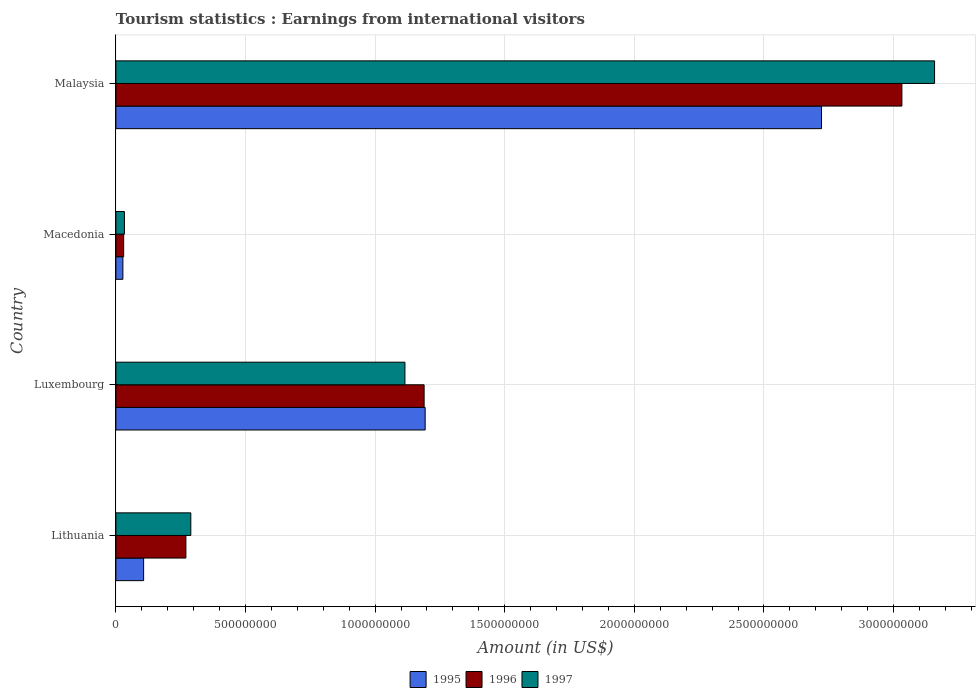Are the number of bars per tick equal to the number of legend labels?
Offer a very short reply. Yes. How many bars are there on the 1st tick from the top?
Provide a succinct answer. 3. How many bars are there on the 2nd tick from the bottom?
Offer a terse response. 3. What is the label of the 4th group of bars from the top?
Provide a succinct answer. Lithuania. In how many cases, is the number of bars for a given country not equal to the number of legend labels?
Provide a short and direct response. 0. What is the earnings from international visitors in 1996 in Lithuania?
Your response must be concise. 2.70e+08. Across all countries, what is the maximum earnings from international visitors in 1997?
Provide a succinct answer. 3.16e+09. Across all countries, what is the minimum earnings from international visitors in 1995?
Make the answer very short. 2.70e+07. In which country was the earnings from international visitors in 1995 maximum?
Make the answer very short. Malaysia. In which country was the earnings from international visitors in 1996 minimum?
Your response must be concise. Macedonia. What is the total earnings from international visitors in 1997 in the graph?
Keep it short and to the point. 4.60e+09. What is the difference between the earnings from international visitors in 1997 in Luxembourg and that in Malaysia?
Keep it short and to the point. -2.04e+09. What is the difference between the earnings from international visitors in 1996 in Luxembourg and the earnings from international visitors in 1997 in Macedonia?
Your answer should be compact. 1.16e+09. What is the average earnings from international visitors in 1995 per country?
Your response must be concise. 1.01e+09. What is the difference between the earnings from international visitors in 1996 and earnings from international visitors in 1995 in Malaysia?
Provide a succinct answer. 3.10e+08. In how many countries, is the earnings from international visitors in 1996 greater than 1900000000 US$?
Your response must be concise. 1. What is the ratio of the earnings from international visitors in 1995 in Lithuania to that in Macedonia?
Make the answer very short. 3.96. Is the earnings from international visitors in 1997 in Lithuania less than that in Macedonia?
Your answer should be compact. No. What is the difference between the highest and the second highest earnings from international visitors in 1997?
Offer a very short reply. 2.04e+09. What is the difference between the highest and the lowest earnings from international visitors in 1995?
Your answer should be very brief. 2.70e+09. Is the sum of the earnings from international visitors in 1995 in Lithuania and Macedonia greater than the maximum earnings from international visitors in 1996 across all countries?
Provide a short and direct response. No. What does the 3rd bar from the bottom in Luxembourg represents?
Offer a very short reply. 1997. Is it the case that in every country, the sum of the earnings from international visitors in 1997 and earnings from international visitors in 1995 is greater than the earnings from international visitors in 1996?
Provide a short and direct response. Yes. How many bars are there?
Offer a very short reply. 12. Are all the bars in the graph horizontal?
Give a very brief answer. Yes. Are the values on the major ticks of X-axis written in scientific E-notation?
Give a very brief answer. No. Does the graph contain grids?
Give a very brief answer. Yes. How are the legend labels stacked?
Give a very brief answer. Horizontal. What is the title of the graph?
Ensure brevity in your answer.  Tourism statistics : Earnings from international visitors. What is the label or title of the X-axis?
Give a very brief answer. Amount (in US$). What is the label or title of the Y-axis?
Provide a succinct answer. Country. What is the Amount (in US$) of 1995 in Lithuania?
Make the answer very short. 1.07e+08. What is the Amount (in US$) in 1996 in Lithuania?
Your response must be concise. 2.70e+08. What is the Amount (in US$) in 1997 in Lithuania?
Offer a very short reply. 2.89e+08. What is the Amount (in US$) in 1995 in Luxembourg?
Your response must be concise. 1.19e+09. What is the Amount (in US$) of 1996 in Luxembourg?
Provide a succinct answer. 1.19e+09. What is the Amount (in US$) of 1997 in Luxembourg?
Keep it short and to the point. 1.12e+09. What is the Amount (in US$) of 1995 in Macedonia?
Keep it short and to the point. 2.70e+07. What is the Amount (in US$) in 1996 in Macedonia?
Provide a succinct answer. 3.00e+07. What is the Amount (in US$) of 1997 in Macedonia?
Your answer should be very brief. 3.30e+07. What is the Amount (in US$) of 1995 in Malaysia?
Keep it short and to the point. 2.72e+09. What is the Amount (in US$) in 1996 in Malaysia?
Your answer should be compact. 3.03e+09. What is the Amount (in US$) in 1997 in Malaysia?
Your answer should be compact. 3.16e+09. Across all countries, what is the maximum Amount (in US$) in 1995?
Provide a succinct answer. 2.72e+09. Across all countries, what is the maximum Amount (in US$) in 1996?
Keep it short and to the point. 3.03e+09. Across all countries, what is the maximum Amount (in US$) of 1997?
Provide a short and direct response. 3.16e+09. Across all countries, what is the minimum Amount (in US$) in 1995?
Give a very brief answer. 2.70e+07. Across all countries, what is the minimum Amount (in US$) of 1996?
Your response must be concise. 3.00e+07. Across all countries, what is the minimum Amount (in US$) of 1997?
Your response must be concise. 3.30e+07. What is the total Amount (in US$) in 1995 in the graph?
Offer a very short reply. 4.05e+09. What is the total Amount (in US$) in 1996 in the graph?
Your answer should be very brief. 4.52e+09. What is the total Amount (in US$) in 1997 in the graph?
Give a very brief answer. 4.60e+09. What is the difference between the Amount (in US$) of 1995 in Lithuania and that in Luxembourg?
Your response must be concise. -1.09e+09. What is the difference between the Amount (in US$) in 1996 in Lithuania and that in Luxembourg?
Your answer should be very brief. -9.19e+08. What is the difference between the Amount (in US$) of 1997 in Lithuania and that in Luxembourg?
Ensure brevity in your answer.  -8.26e+08. What is the difference between the Amount (in US$) of 1995 in Lithuania and that in Macedonia?
Make the answer very short. 8.00e+07. What is the difference between the Amount (in US$) of 1996 in Lithuania and that in Macedonia?
Provide a succinct answer. 2.40e+08. What is the difference between the Amount (in US$) in 1997 in Lithuania and that in Macedonia?
Offer a very short reply. 2.56e+08. What is the difference between the Amount (in US$) of 1995 in Lithuania and that in Malaysia?
Your answer should be compact. -2.62e+09. What is the difference between the Amount (in US$) in 1996 in Lithuania and that in Malaysia?
Ensure brevity in your answer.  -2.76e+09. What is the difference between the Amount (in US$) of 1997 in Lithuania and that in Malaysia?
Keep it short and to the point. -2.87e+09. What is the difference between the Amount (in US$) of 1995 in Luxembourg and that in Macedonia?
Provide a short and direct response. 1.17e+09. What is the difference between the Amount (in US$) in 1996 in Luxembourg and that in Macedonia?
Offer a terse response. 1.16e+09. What is the difference between the Amount (in US$) in 1997 in Luxembourg and that in Macedonia?
Your answer should be very brief. 1.08e+09. What is the difference between the Amount (in US$) of 1995 in Luxembourg and that in Malaysia?
Keep it short and to the point. -1.53e+09. What is the difference between the Amount (in US$) of 1996 in Luxembourg and that in Malaysia?
Your answer should be compact. -1.84e+09. What is the difference between the Amount (in US$) in 1997 in Luxembourg and that in Malaysia?
Provide a succinct answer. -2.04e+09. What is the difference between the Amount (in US$) of 1995 in Macedonia and that in Malaysia?
Your response must be concise. -2.70e+09. What is the difference between the Amount (in US$) of 1996 in Macedonia and that in Malaysia?
Ensure brevity in your answer.  -3.00e+09. What is the difference between the Amount (in US$) in 1997 in Macedonia and that in Malaysia?
Offer a very short reply. -3.12e+09. What is the difference between the Amount (in US$) of 1995 in Lithuania and the Amount (in US$) of 1996 in Luxembourg?
Give a very brief answer. -1.08e+09. What is the difference between the Amount (in US$) of 1995 in Lithuania and the Amount (in US$) of 1997 in Luxembourg?
Your answer should be very brief. -1.01e+09. What is the difference between the Amount (in US$) in 1996 in Lithuania and the Amount (in US$) in 1997 in Luxembourg?
Make the answer very short. -8.45e+08. What is the difference between the Amount (in US$) of 1995 in Lithuania and the Amount (in US$) of 1996 in Macedonia?
Your answer should be compact. 7.70e+07. What is the difference between the Amount (in US$) in 1995 in Lithuania and the Amount (in US$) in 1997 in Macedonia?
Your response must be concise. 7.40e+07. What is the difference between the Amount (in US$) in 1996 in Lithuania and the Amount (in US$) in 1997 in Macedonia?
Keep it short and to the point. 2.37e+08. What is the difference between the Amount (in US$) in 1995 in Lithuania and the Amount (in US$) in 1996 in Malaysia?
Make the answer very short. -2.92e+09. What is the difference between the Amount (in US$) of 1995 in Lithuania and the Amount (in US$) of 1997 in Malaysia?
Ensure brevity in your answer.  -3.05e+09. What is the difference between the Amount (in US$) in 1996 in Lithuania and the Amount (in US$) in 1997 in Malaysia?
Offer a very short reply. -2.89e+09. What is the difference between the Amount (in US$) of 1995 in Luxembourg and the Amount (in US$) of 1996 in Macedonia?
Offer a very short reply. 1.16e+09. What is the difference between the Amount (in US$) in 1995 in Luxembourg and the Amount (in US$) in 1997 in Macedonia?
Keep it short and to the point. 1.16e+09. What is the difference between the Amount (in US$) in 1996 in Luxembourg and the Amount (in US$) in 1997 in Macedonia?
Offer a very short reply. 1.16e+09. What is the difference between the Amount (in US$) in 1995 in Luxembourg and the Amount (in US$) in 1996 in Malaysia?
Give a very brief answer. -1.84e+09. What is the difference between the Amount (in US$) in 1995 in Luxembourg and the Amount (in US$) in 1997 in Malaysia?
Keep it short and to the point. -1.96e+09. What is the difference between the Amount (in US$) in 1996 in Luxembourg and the Amount (in US$) in 1997 in Malaysia?
Keep it short and to the point. -1.97e+09. What is the difference between the Amount (in US$) in 1995 in Macedonia and the Amount (in US$) in 1996 in Malaysia?
Make the answer very short. -3.00e+09. What is the difference between the Amount (in US$) of 1995 in Macedonia and the Amount (in US$) of 1997 in Malaysia?
Ensure brevity in your answer.  -3.13e+09. What is the difference between the Amount (in US$) of 1996 in Macedonia and the Amount (in US$) of 1997 in Malaysia?
Keep it short and to the point. -3.13e+09. What is the average Amount (in US$) in 1995 per country?
Give a very brief answer. 1.01e+09. What is the average Amount (in US$) in 1996 per country?
Keep it short and to the point. 1.13e+09. What is the average Amount (in US$) in 1997 per country?
Ensure brevity in your answer.  1.15e+09. What is the difference between the Amount (in US$) of 1995 and Amount (in US$) of 1996 in Lithuania?
Your response must be concise. -1.63e+08. What is the difference between the Amount (in US$) in 1995 and Amount (in US$) in 1997 in Lithuania?
Give a very brief answer. -1.82e+08. What is the difference between the Amount (in US$) of 1996 and Amount (in US$) of 1997 in Lithuania?
Your answer should be very brief. -1.90e+07. What is the difference between the Amount (in US$) of 1995 and Amount (in US$) of 1997 in Luxembourg?
Your answer should be very brief. 7.80e+07. What is the difference between the Amount (in US$) in 1996 and Amount (in US$) in 1997 in Luxembourg?
Your response must be concise. 7.40e+07. What is the difference between the Amount (in US$) of 1995 and Amount (in US$) of 1996 in Macedonia?
Provide a short and direct response. -3.00e+06. What is the difference between the Amount (in US$) in 1995 and Amount (in US$) in 1997 in Macedonia?
Give a very brief answer. -6.00e+06. What is the difference between the Amount (in US$) in 1995 and Amount (in US$) in 1996 in Malaysia?
Offer a very short reply. -3.10e+08. What is the difference between the Amount (in US$) of 1995 and Amount (in US$) of 1997 in Malaysia?
Make the answer very short. -4.36e+08. What is the difference between the Amount (in US$) in 1996 and Amount (in US$) in 1997 in Malaysia?
Your response must be concise. -1.26e+08. What is the ratio of the Amount (in US$) of 1995 in Lithuania to that in Luxembourg?
Make the answer very short. 0.09. What is the ratio of the Amount (in US$) in 1996 in Lithuania to that in Luxembourg?
Keep it short and to the point. 0.23. What is the ratio of the Amount (in US$) of 1997 in Lithuania to that in Luxembourg?
Provide a short and direct response. 0.26. What is the ratio of the Amount (in US$) of 1995 in Lithuania to that in Macedonia?
Provide a succinct answer. 3.96. What is the ratio of the Amount (in US$) of 1997 in Lithuania to that in Macedonia?
Your answer should be compact. 8.76. What is the ratio of the Amount (in US$) in 1995 in Lithuania to that in Malaysia?
Your answer should be very brief. 0.04. What is the ratio of the Amount (in US$) in 1996 in Lithuania to that in Malaysia?
Offer a terse response. 0.09. What is the ratio of the Amount (in US$) in 1997 in Lithuania to that in Malaysia?
Make the answer very short. 0.09. What is the ratio of the Amount (in US$) in 1995 in Luxembourg to that in Macedonia?
Your answer should be very brief. 44.19. What is the ratio of the Amount (in US$) in 1996 in Luxembourg to that in Macedonia?
Your response must be concise. 39.63. What is the ratio of the Amount (in US$) in 1997 in Luxembourg to that in Macedonia?
Offer a very short reply. 33.79. What is the ratio of the Amount (in US$) of 1995 in Luxembourg to that in Malaysia?
Offer a terse response. 0.44. What is the ratio of the Amount (in US$) of 1996 in Luxembourg to that in Malaysia?
Your answer should be very brief. 0.39. What is the ratio of the Amount (in US$) of 1997 in Luxembourg to that in Malaysia?
Keep it short and to the point. 0.35. What is the ratio of the Amount (in US$) of 1995 in Macedonia to that in Malaysia?
Your response must be concise. 0.01. What is the ratio of the Amount (in US$) in 1996 in Macedonia to that in Malaysia?
Ensure brevity in your answer.  0.01. What is the ratio of the Amount (in US$) of 1997 in Macedonia to that in Malaysia?
Your response must be concise. 0.01. What is the difference between the highest and the second highest Amount (in US$) in 1995?
Offer a terse response. 1.53e+09. What is the difference between the highest and the second highest Amount (in US$) of 1996?
Your answer should be very brief. 1.84e+09. What is the difference between the highest and the second highest Amount (in US$) in 1997?
Provide a short and direct response. 2.04e+09. What is the difference between the highest and the lowest Amount (in US$) in 1995?
Ensure brevity in your answer.  2.70e+09. What is the difference between the highest and the lowest Amount (in US$) in 1996?
Keep it short and to the point. 3.00e+09. What is the difference between the highest and the lowest Amount (in US$) in 1997?
Keep it short and to the point. 3.12e+09. 